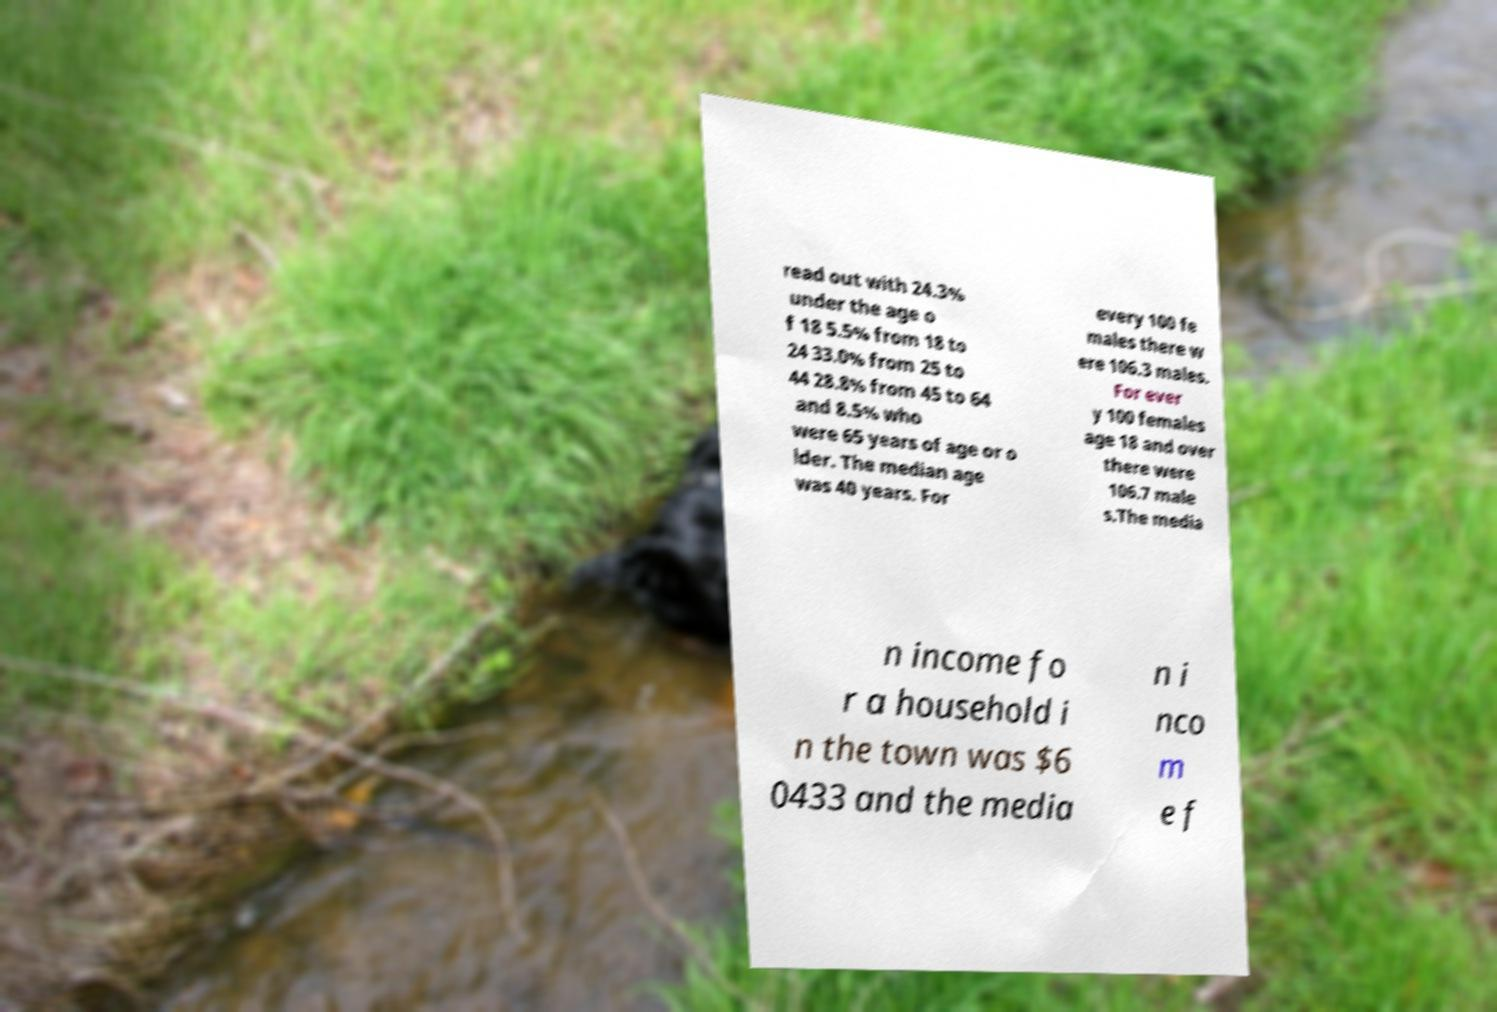What messages or text are displayed in this image? I need them in a readable, typed format. read out with 24.3% under the age o f 18 5.5% from 18 to 24 33.0% from 25 to 44 28.8% from 45 to 64 and 8.5% who were 65 years of age or o lder. The median age was 40 years. For every 100 fe males there w ere 106.3 males. For ever y 100 females age 18 and over there were 106.7 male s.The media n income fo r a household i n the town was $6 0433 and the media n i nco m e f 